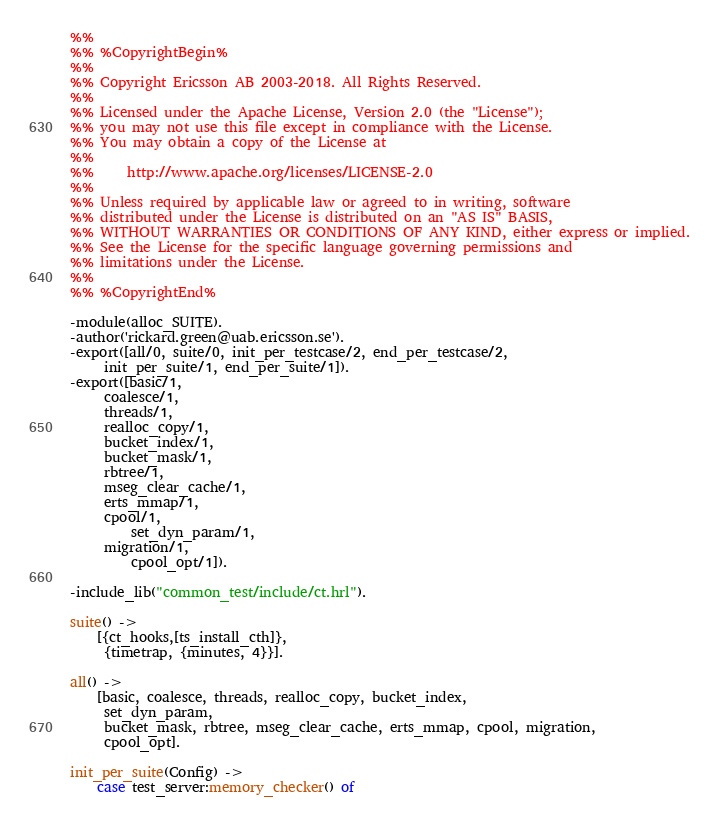Convert code to text. <code><loc_0><loc_0><loc_500><loc_500><_Erlang_>%%
%% %CopyrightBegin%
%% 
%% Copyright Ericsson AB 2003-2018. All Rights Reserved.
%% 
%% Licensed under the Apache License, Version 2.0 (the "License");
%% you may not use this file except in compliance with the License.
%% You may obtain a copy of the License at
%%
%%     http://www.apache.org/licenses/LICENSE-2.0
%%
%% Unless required by applicable law or agreed to in writing, software
%% distributed under the License is distributed on an "AS IS" BASIS,
%% WITHOUT WARRANTIES OR CONDITIONS OF ANY KIND, either express or implied.
%% See the License for the specific language governing permissions and
%% limitations under the License.
%% 
%% %CopyrightEnd%

-module(alloc_SUITE).
-author('rickard.green@uab.ericsson.se').
-export([all/0, suite/0, init_per_testcase/2, end_per_testcase/2,
	 init_per_suite/1, end_per_suite/1]).
-export([basic/1,
	 coalesce/1,
	 threads/1,
	 realloc_copy/1,
	 bucket_index/1,
	 bucket_mask/1,
	 rbtree/1,
	 mseg_clear_cache/1,
	 erts_mmap/1,
	 cpool/1,
         set_dyn_param/1,
	 migration/1,
         cpool_opt/1]).

-include_lib("common_test/include/ct.hrl").

suite() ->
    [{ct_hooks,[ts_install_cth]},
     {timetrap, {minutes, 4}}].

all() -> 
    [basic, coalesce, threads, realloc_copy, bucket_index,
     set_dyn_param,
     bucket_mask, rbtree, mseg_clear_cache, erts_mmap, cpool, migration,
     cpool_opt].

init_per_suite(Config) ->
    case test_server:memory_checker() of</code> 